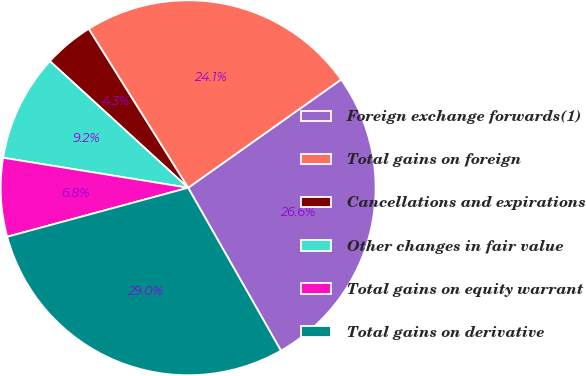<chart> <loc_0><loc_0><loc_500><loc_500><pie_chart><fcel>Foreign exchange forwards(1)<fcel>Total gains on foreign<fcel>Cancellations and expirations<fcel>Other changes in fair value<fcel>Total gains on equity warrant<fcel>Total gains on derivative<nl><fcel>26.56%<fcel>24.1%<fcel>4.3%<fcel>9.24%<fcel>6.77%<fcel>29.03%<nl></chart> 